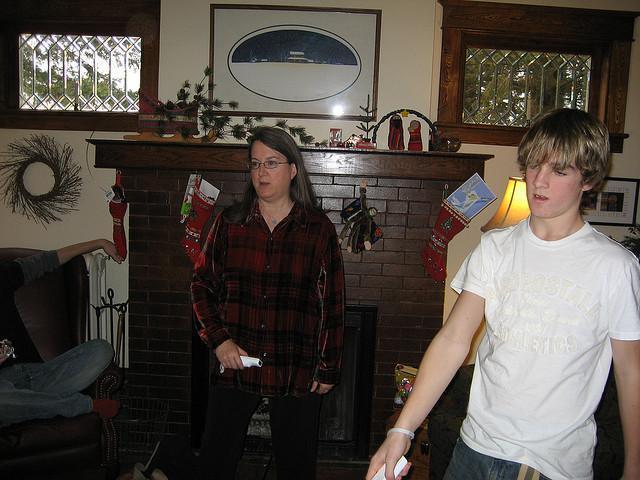How many people are there?
Give a very brief answer. 3. 